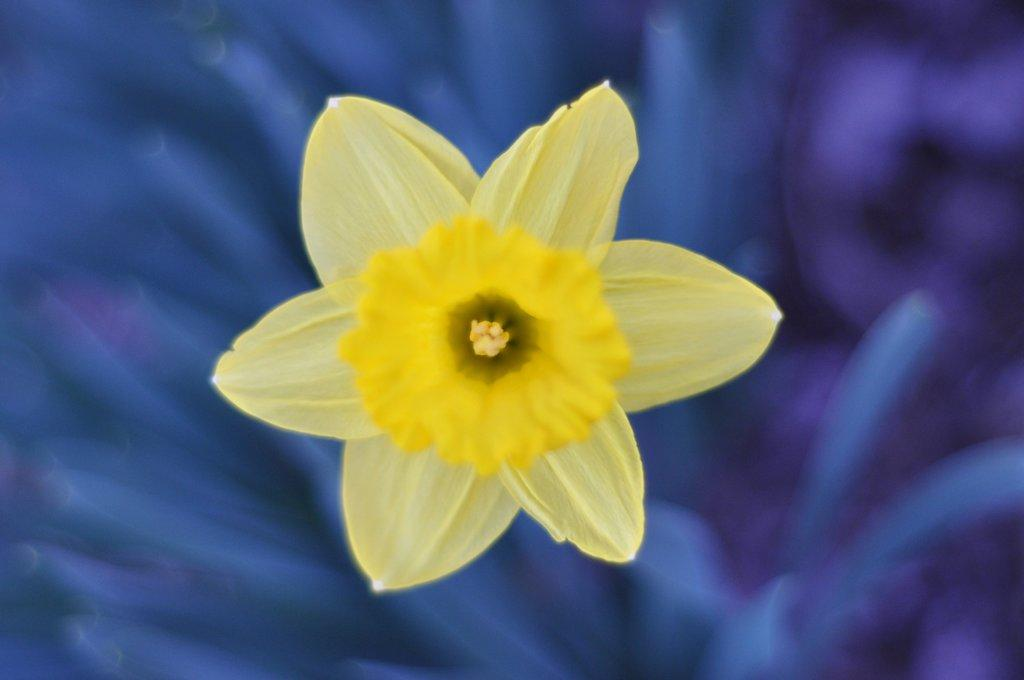What is the main subject of the image? There is a flower in the image. Can you describe the background of the image? The background of the image is blurred. Where is the kettle located in the image? There is no kettle present in the image. What type of back is visible in the image? There is no back visible in the image; it is a close-up of a flower. 